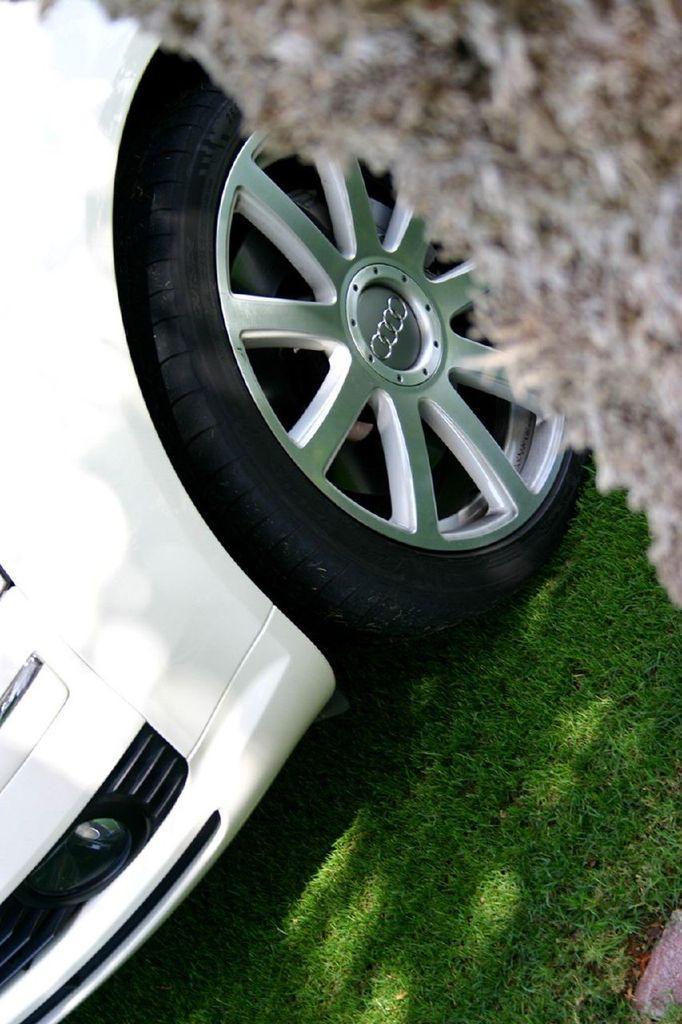How would you summarize this image in a sentence or two? in this image in the front there's grass on the ground. In the center there is a car. On the right side there is an object which is visible. 